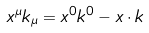<formula> <loc_0><loc_0><loc_500><loc_500>x ^ { \mu } k _ { \mu } = x ^ { 0 } k ^ { 0 } - { x } \cdot { k }</formula> 